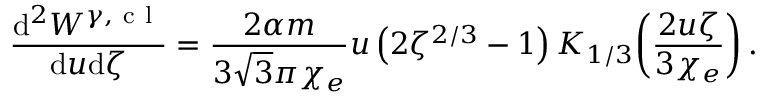<formula> <loc_0><loc_0><loc_500><loc_500>\frac { d ^ { 2 } W ^ { \gamma , c l } } { d u d \zeta } = \frac { 2 \alpha m } { 3 \sqrt { 3 } \pi \chi _ { e } } u \left ( 2 \zeta ^ { 2 / 3 } - 1 \right ) K _ { 1 / 3 } \, \left ( \frac { 2 u \zeta } { 3 \chi _ { e } } \right ) .</formula> 